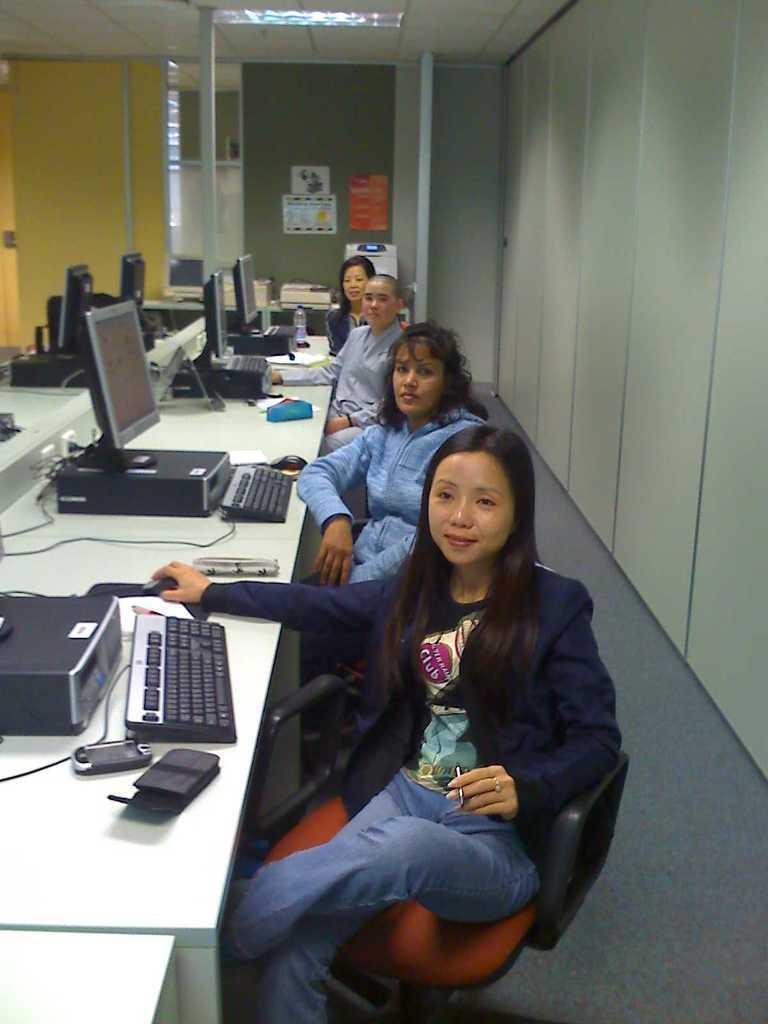Could you give a brief overview of what you see in this image? In the middle of the image four women are sitting and smiling. Bottom left side of the image there is a table, On the table there are some computers and there are some water bottles. Top left side of the image there is a roof and light. Top right side of the image there is a wall. 